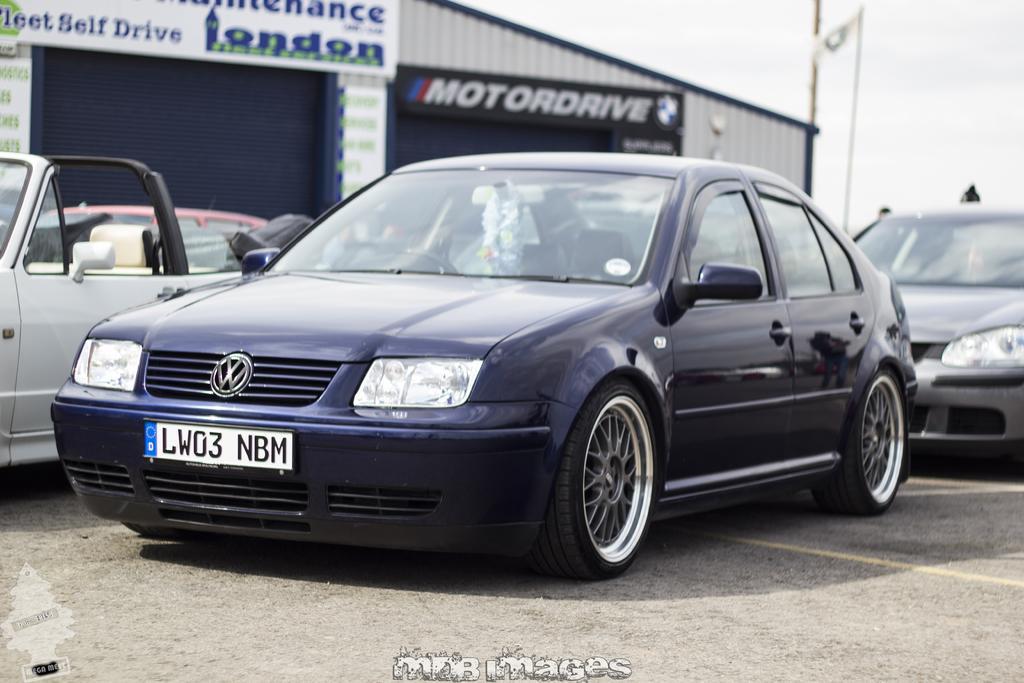Can you describe this image briefly? In this image I can see few vehicles. In front the vehicle is in blue color, background I can see few sheds and I can also see few boards attached to the wall and the sky is in white color. 